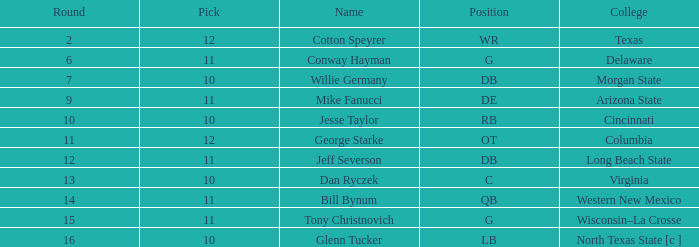What is the lowest round for an overall pick of 349 with a pick number in the round over 11? None. 